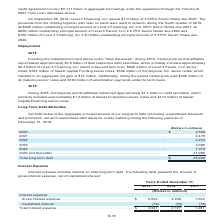According to Centurylink's financial document, What does interest expense include? interest on total long-term debt.. The document states: "Interest expense includes interest on total long-term debt. The following table presents the amount of gross interest expense, net of capitalized inte..." Also, What is the total interest expense in 2019? According to the financial document, $2,021 (in millions). The relevant text states: "Total interest expense . $ 2,021 2,177 1,481..." Also, What segments of interest expense are presented in the table? The document shows two values: Gross interest expense and capitalized interest. From the document: "debt. The following table presents the amount of gross interest expense, net of capitalized interest: nse: Gross interest expense . $ 2,093 2,230 1,55..." Additionally, Which year has the largest total interest expense? According to the financial document, 2018. The relevant text states: "2019 2018 2017..." Also, can you calculate: What is the change in the gross interest expense in 2019 from 2018? Based on the calculation: 2,093-2,230, the result is -137 (in millions). This is based on the information: "nterest expense: Gross interest expense . $ 2,093 2,230 1,559 Capitalized interest . (72) (53) (78) ons) Interest expense: Gross interest expense . $ 2,093 2,230 1,559 Capitalized interest . (72) (53)..." The key data points involved are: 2,093, 2,230. Also, can you calculate: What is the average total interest expense for 2017 to 2019? To answer this question, I need to perform calculations using the financial data. The calculation is: (2,021+2,177+1,481)/3, which equals 1893 (in millions). This is based on the information: "Total interest expense . $ 2,021 2,177 1,481 Total interest expense . $ 2,021 2,177 1,481 Total interest expense . $ 2,021 2,177 1,481..." The key data points involved are: 1,481, 2,021, 2,177. 